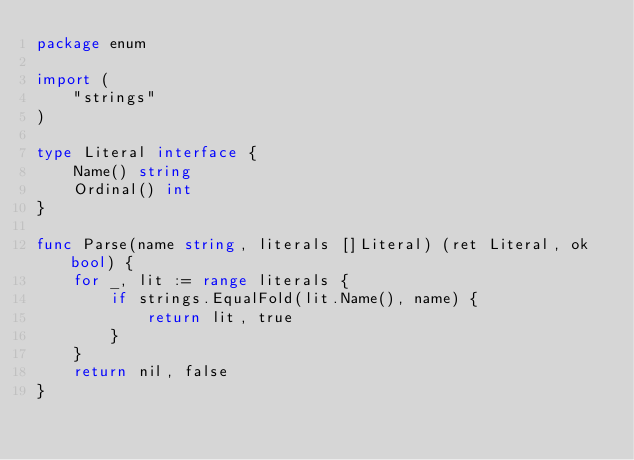Convert code to text. <code><loc_0><loc_0><loc_500><loc_500><_Go_>package enum

import (
	"strings"
)

type Literal interface {
	Name() string
	Ordinal() int
}

func Parse(name string, literals []Literal) (ret Literal, ok bool) {
	for _, lit := range literals {
		if strings.EqualFold(lit.Name(), name) {
			return lit, true
		}
	}
	return nil, false
}</code> 